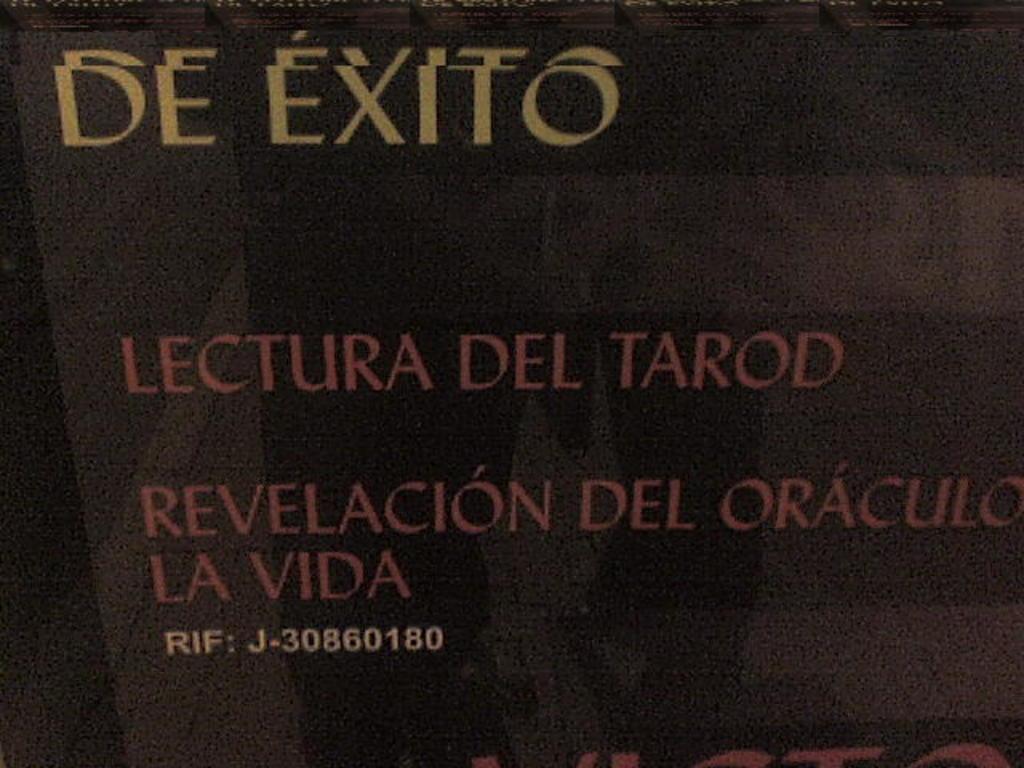What is the rif #?
Keep it short and to the point. J-30860180. What are the words in yellow on the top of the album?
Give a very brief answer. De exito. 